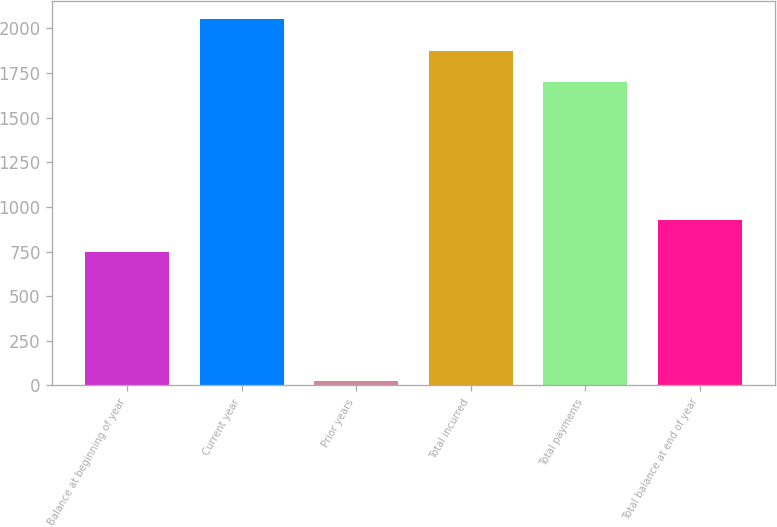Convert chart. <chart><loc_0><loc_0><loc_500><loc_500><bar_chart><fcel>Balance at beginning of year<fcel>Current year<fcel>Prior years<fcel>Total incurred<fcel>Total payments<fcel>Total balance at end of year<nl><fcel>747.6<fcel>2050.8<fcel>22<fcel>1874.3<fcel>1697.8<fcel>924.1<nl></chart> 